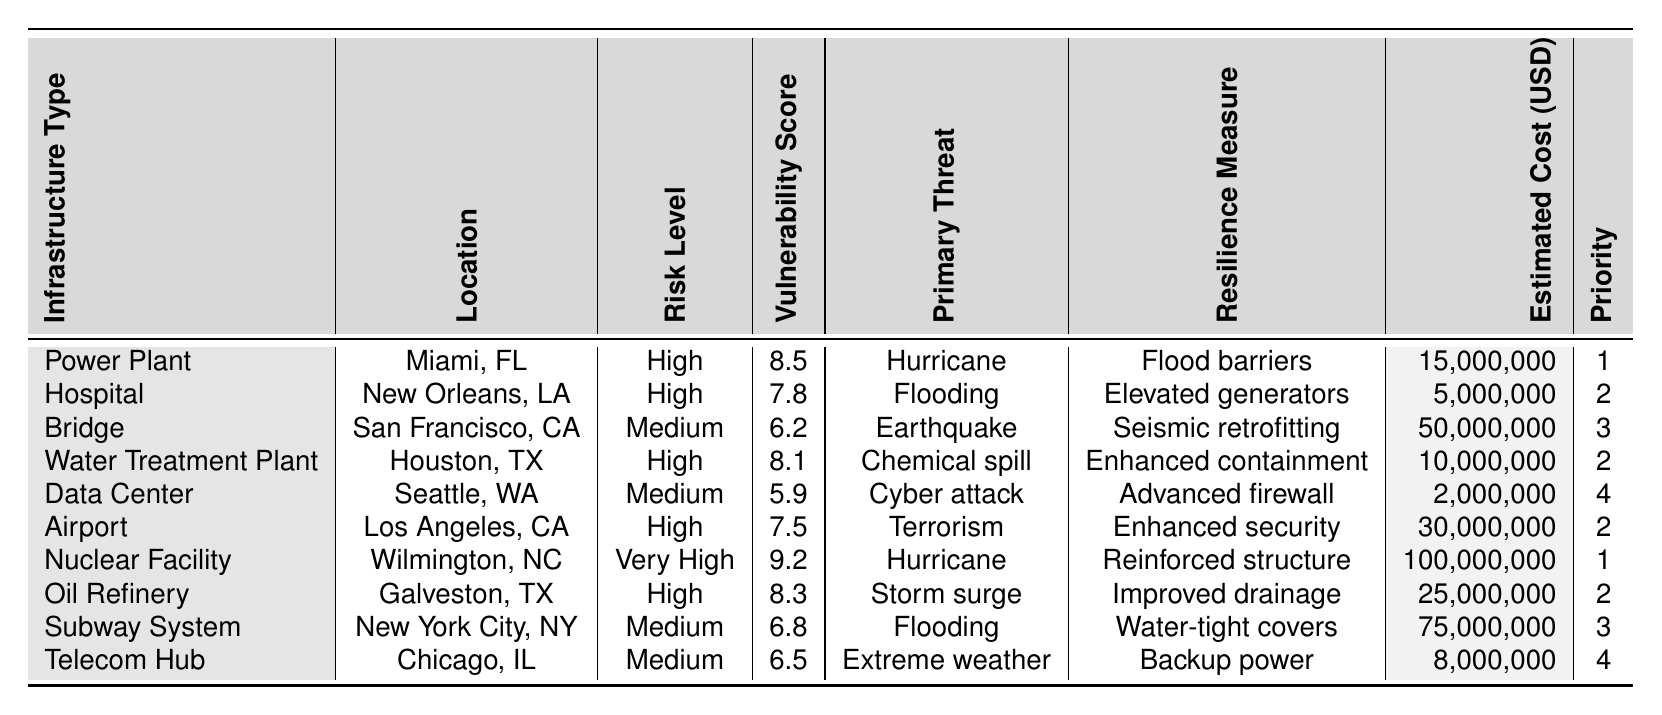What is the vulnerability score of the Nuclear Facility? The Nuclear Facility in Wilmington, North Carolina has a vulnerability score listed in the table, which is directly accessible without any calculations needed.
Answer: 9.2 Which infrastructure has the highest estimated cost for resilience measures? By comparing the estimated costs provided for each infrastructure, it is evident that the Nuclear Facility has the highest estimated cost of $100,000,000.
Answer: $100,000,000 How many infrastructures are classified as having a high-risk level? The table categorizes the infrastructures based on risk levels. By counting those marked as high, we find that there are five infrastructures labeled as high risk.
Answer: 5 What is the average vulnerability score of all infrastructures? To find the average, I sum the vulnerability scores (8.5 + 7.8 + 6.2 + 8.1 + 5.9 + 7.5 + 9.2 + 8.3 + 6.8 + 6.5) which equals 69.8. Dividing this by the total number of infrastructures, which is 10, gives an average of 6.98.
Answer: 6.98 Is there any infrastructure with a "Very High" risk level listed in the table? Upon examining the risk levels of all infrastructures, I find that the Nuclear Facility is the only one marked as having a "Very High" risk level.
Answer: Yes What is the difference between the highest and lowest vulnerability scores in the table? The highest vulnerability score is 9.2 (Nuclear Facility), and the lowest is 5.9 (Data Center). Subtracting gives a difference of 3.3 (9.2 - 5.9).
Answer: 3.3 Which type of infrastructure has the lowest priority ranking? By reviewing the priority column, the Data Center and Telecommunications Hub both have a priority ranking of 4, which is the lowest among all the listed infrastructures.
Answer: Data Center and Telecommunications Hub Which infrastructure is located in Los Angeles, California, and what is its vulnerability score? Looking at the table, the Airport is located in Los Angeles, California, and its vulnerability score is 7.5 as noted.
Answer: 7.5 How do the resilience measures of high-risk infrastructures compare to those of medium-risk infrastructures? High-risk infrastructures list measures such as flood barriers and enhanced security, while medium-risk infrastructures typically have measures like advanced firewalls. This indicates that high-risk measures focus on immediate physical threats, while medium-risk measures focus more on technological threats and preparedness.
Answer: High-risk measures are more focused on physical threats Which infrastructure type faces the threat of a hurricane? According to the table, the Nuclear Facility and the Power Plant are both identified as facing the threat of hurricanes.
Answer: Nuclear Facility and Power Plant 